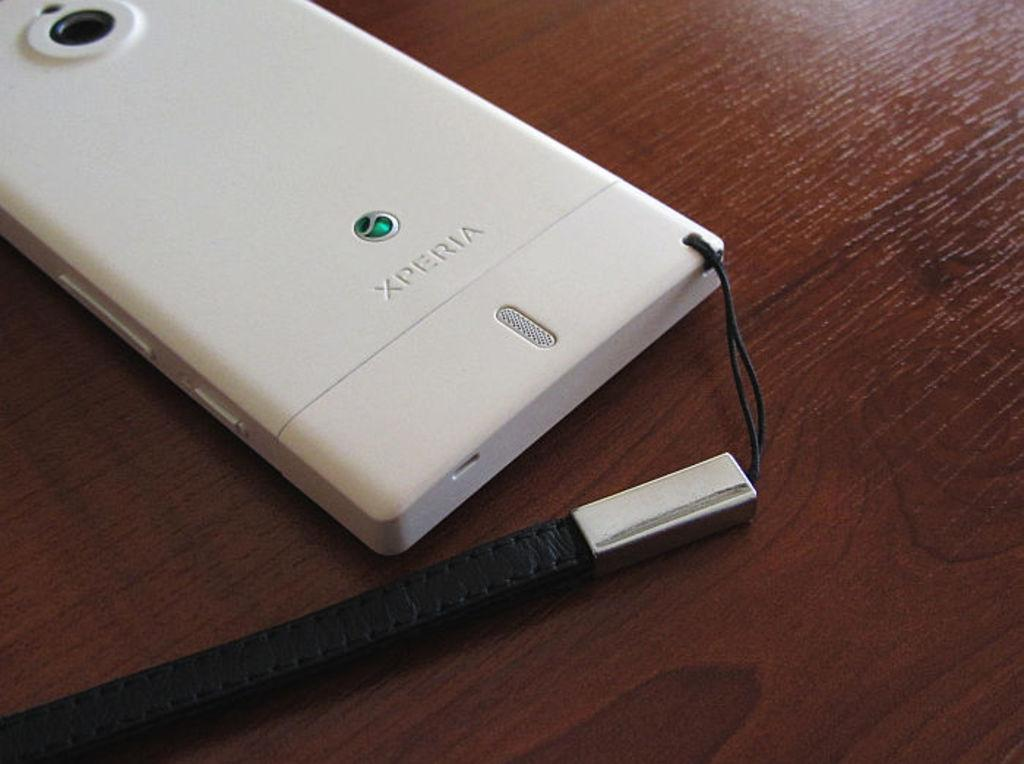What object can be seen in the image? There is a mobile in the image. Where is the mobile located? The mobile is placed on a table. How many sheep are present in the image? There are no sheep present in the image; it only features a mobile on a table. 